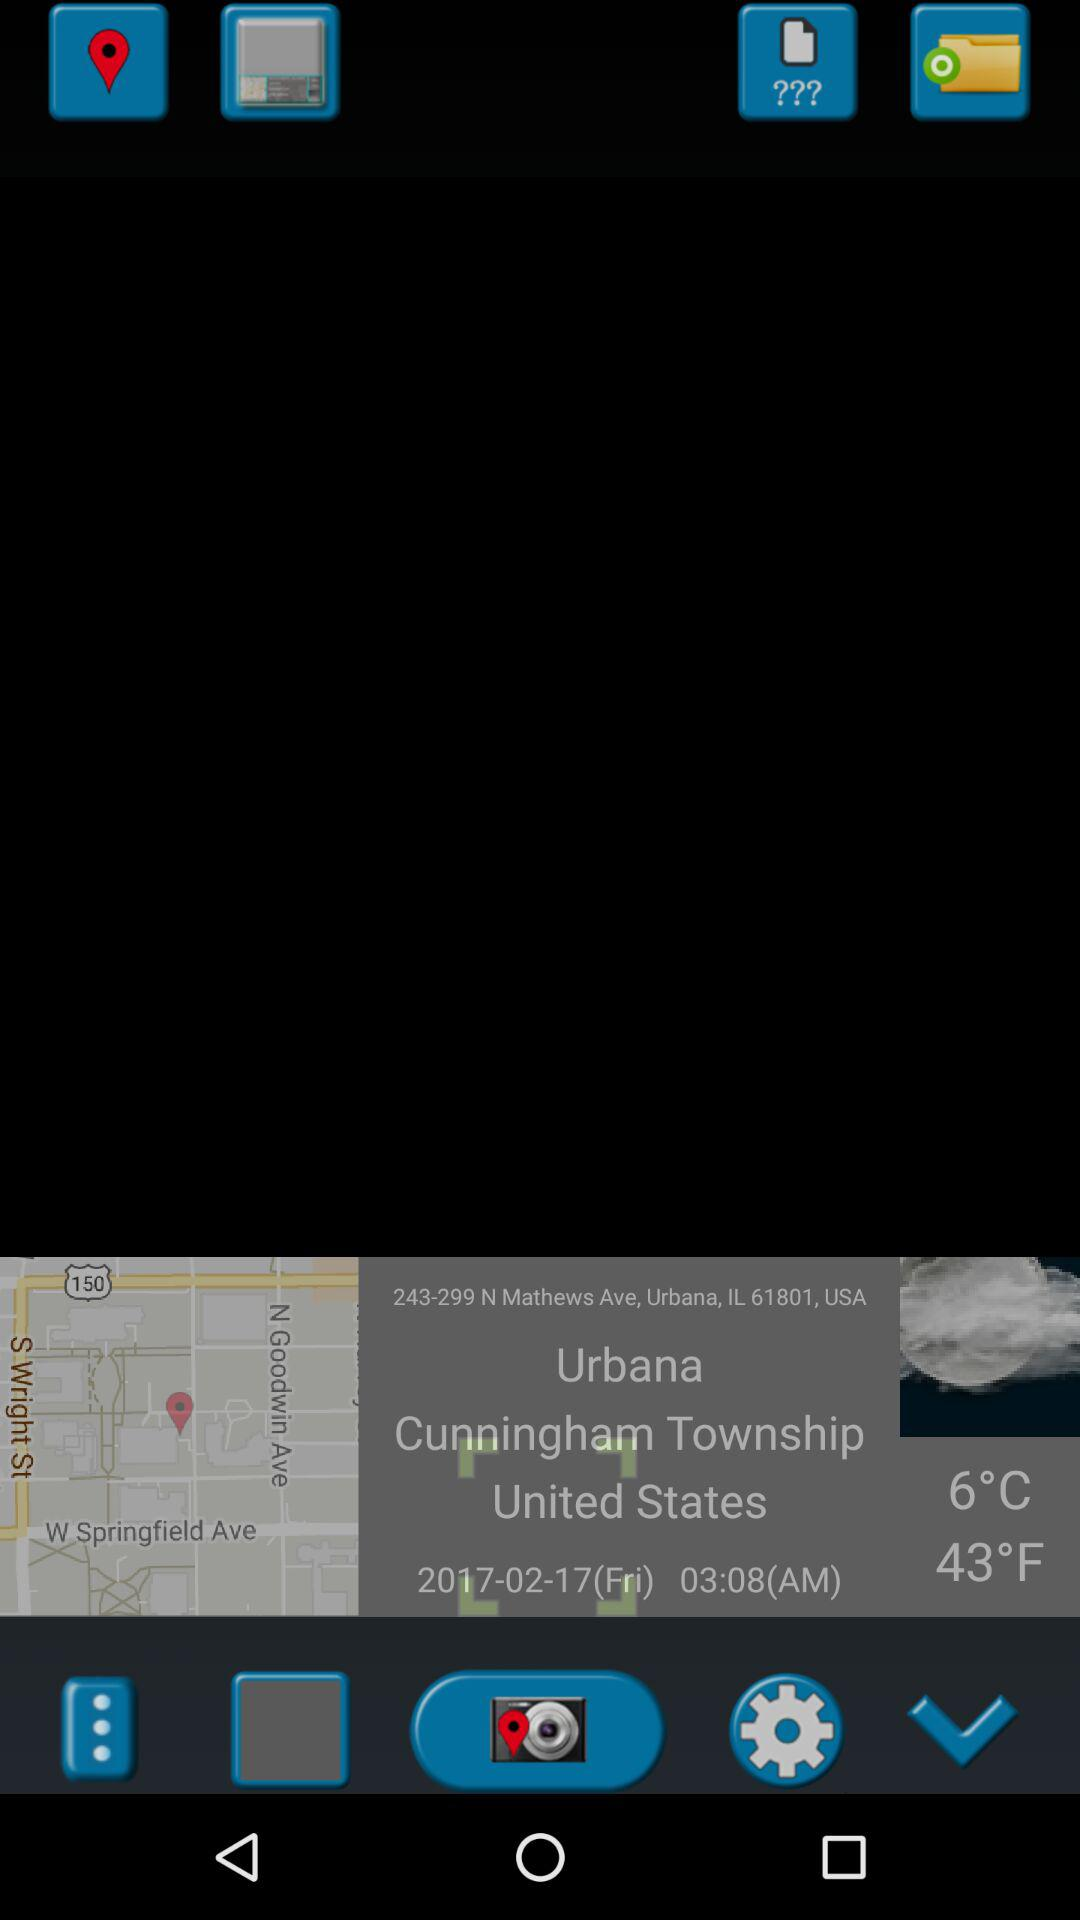What is the address of the location?
Answer the question using a single word or phrase. 243-299 N Mathews Ave, Urbana, IL 61801, USA 